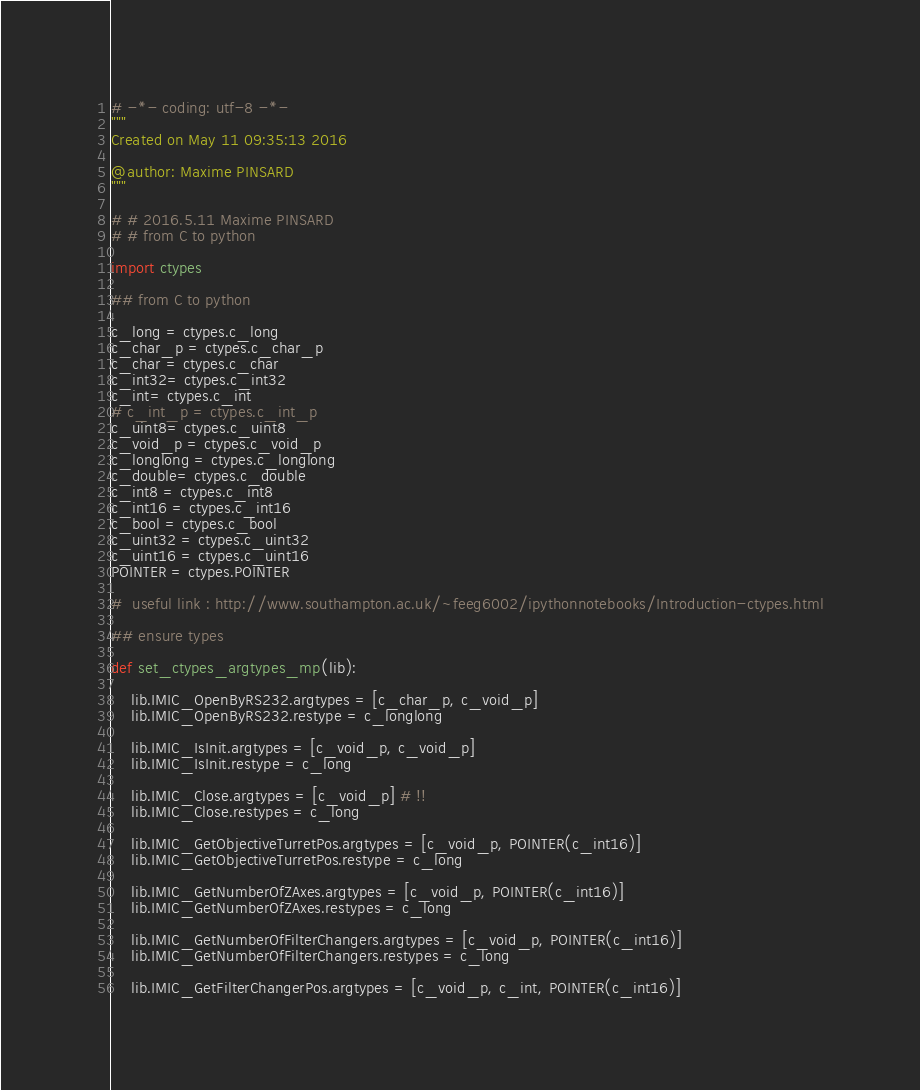<code> <loc_0><loc_0><loc_500><loc_500><_Python_># -*- coding: utf-8 -*-
"""
Created on May 11 09:35:13 2016

@author: Maxime PINSARD
""" 

# # 2016.5.11 Maxime PINSARD
# # from C to python

import ctypes

## from C to python

c_long = ctypes.c_long
c_char_p = ctypes.c_char_p
c_char = ctypes.c_char
c_int32= ctypes.c_int32
c_int= ctypes.c_int
# c_int_p = ctypes.c_int_p
c_uint8= ctypes.c_uint8
c_void_p = ctypes.c_void_p
c_longlong = ctypes.c_longlong
c_double= ctypes.c_double
c_int8 = ctypes.c_int8
c_int16 = ctypes.c_int16
c_bool = ctypes.c_bool
c_uint32 = ctypes.c_uint32
c_uint16 = ctypes.c_uint16
POINTER = ctypes.POINTER

#  useful link : http://www.southampton.ac.uk/~feeg6002/ipythonnotebooks/Introduction-ctypes.html

## ensure types

def set_ctypes_argtypes_mp(lib):

    lib.IMIC_OpenByRS232.argtypes = [c_char_p, c_void_p]
    lib.IMIC_OpenByRS232.restype = c_longlong
    
    lib.IMIC_IsInit.argtypes = [c_void_p, c_void_p]
    lib.IMIC_IsInit.restype = c_long
    
    lib.IMIC_Close.argtypes = [c_void_p] # !!
    lib.IMIC_Close.restypes = c_long

    lib.IMIC_GetObjectiveTurretPos.argtypes = [c_void_p, POINTER(c_int16)]
    lib.IMIC_GetObjectiveTurretPos.restype = c_long
    
    lib.IMIC_GetNumberOfZAxes.argtypes = [c_void_p, POINTER(c_int16)]
    lib.IMIC_GetNumberOfZAxes.restypes = c_long
    
    lib.IMIC_GetNumberOfFilterChangers.argtypes = [c_void_p, POINTER(c_int16)]
    lib.IMIC_GetNumberOfFilterChangers.restypes = c_long
    
    lib.IMIC_GetFilterChangerPos.argtypes = [c_void_p, c_int, POINTER(c_int16)]</code> 